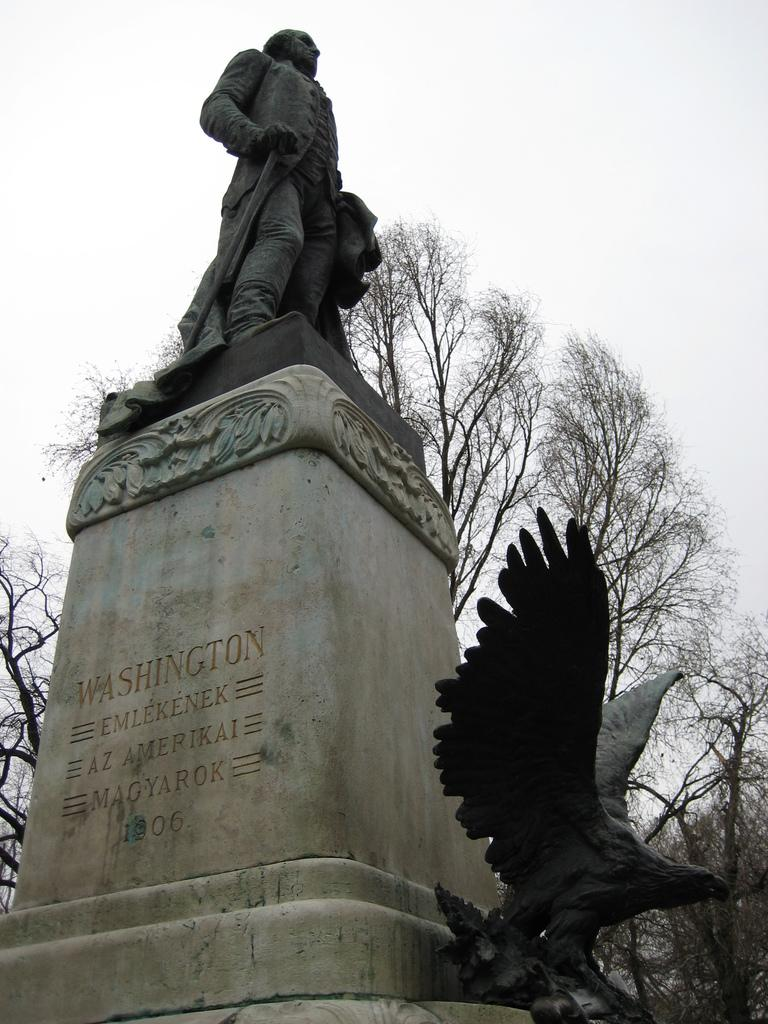What is the main subject in the image? There is a statue of a man in the image. What is written or depicted below the statue of the man? There is text below the statue of the man. What other statue can be seen in front of the statue of the man? There is a bird statue in front of the statue of the man. What type of natural element is visible in the background of the image? There is a tree visible in the background of the image. What is visible above the tree in the image? The sky is visible above the tree. How many boys are standing next to the statue of the man in the image? There are no boys present in the image; it features a statue of a man and a bird statue. 